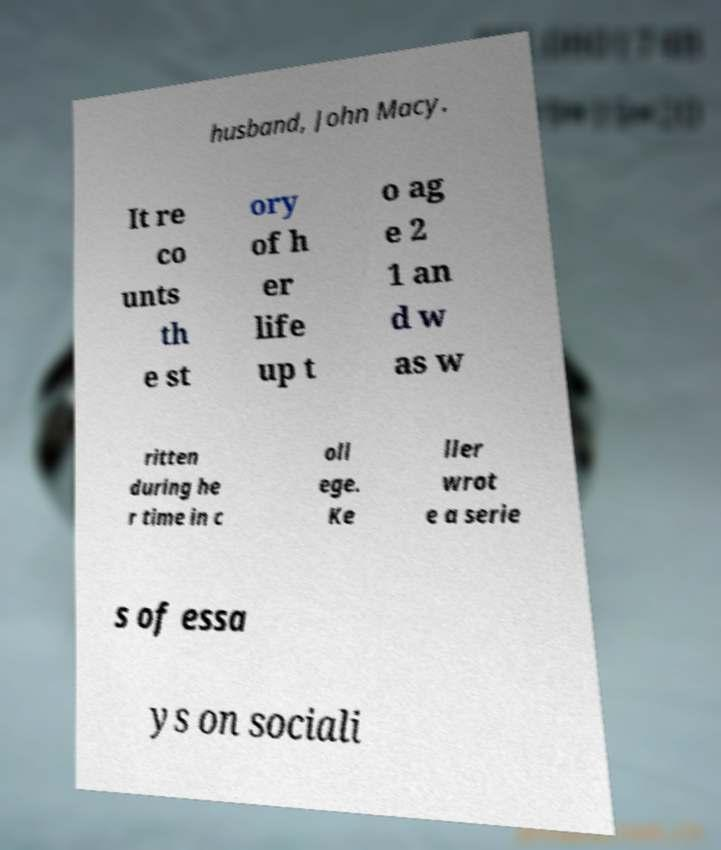Could you extract and type out the text from this image? husband, John Macy. It re co unts th e st ory of h er life up t o ag e 2 1 an d w as w ritten during he r time in c oll ege. Ke ller wrot e a serie s of essa ys on sociali 